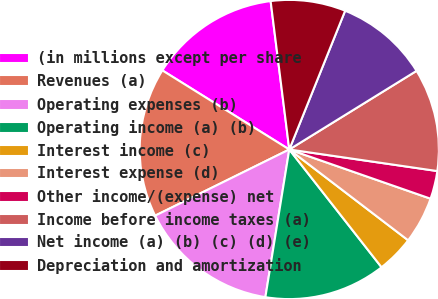Convert chart. <chart><loc_0><loc_0><loc_500><loc_500><pie_chart><fcel>(in millions except per share<fcel>Revenues (a)<fcel>Operating expenses (b)<fcel>Operating income (a) (b)<fcel>Interest income (c)<fcel>Interest expense (d)<fcel>Other income/(expense) net<fcel>Income before income taxes (a)<fcel>Net income (a) (b) (c) (d) (e)<fcel>Depreciation and amortization<nl><fcel>14.14%<fcel>16.16%<fcel>15.15%<fcel>13.13%<fcel>4.04%<fcel>5.05%<fcel>3.03%<fcel>11.11%<fcel>10.1%<fcel>8.08%<nl></chart> 